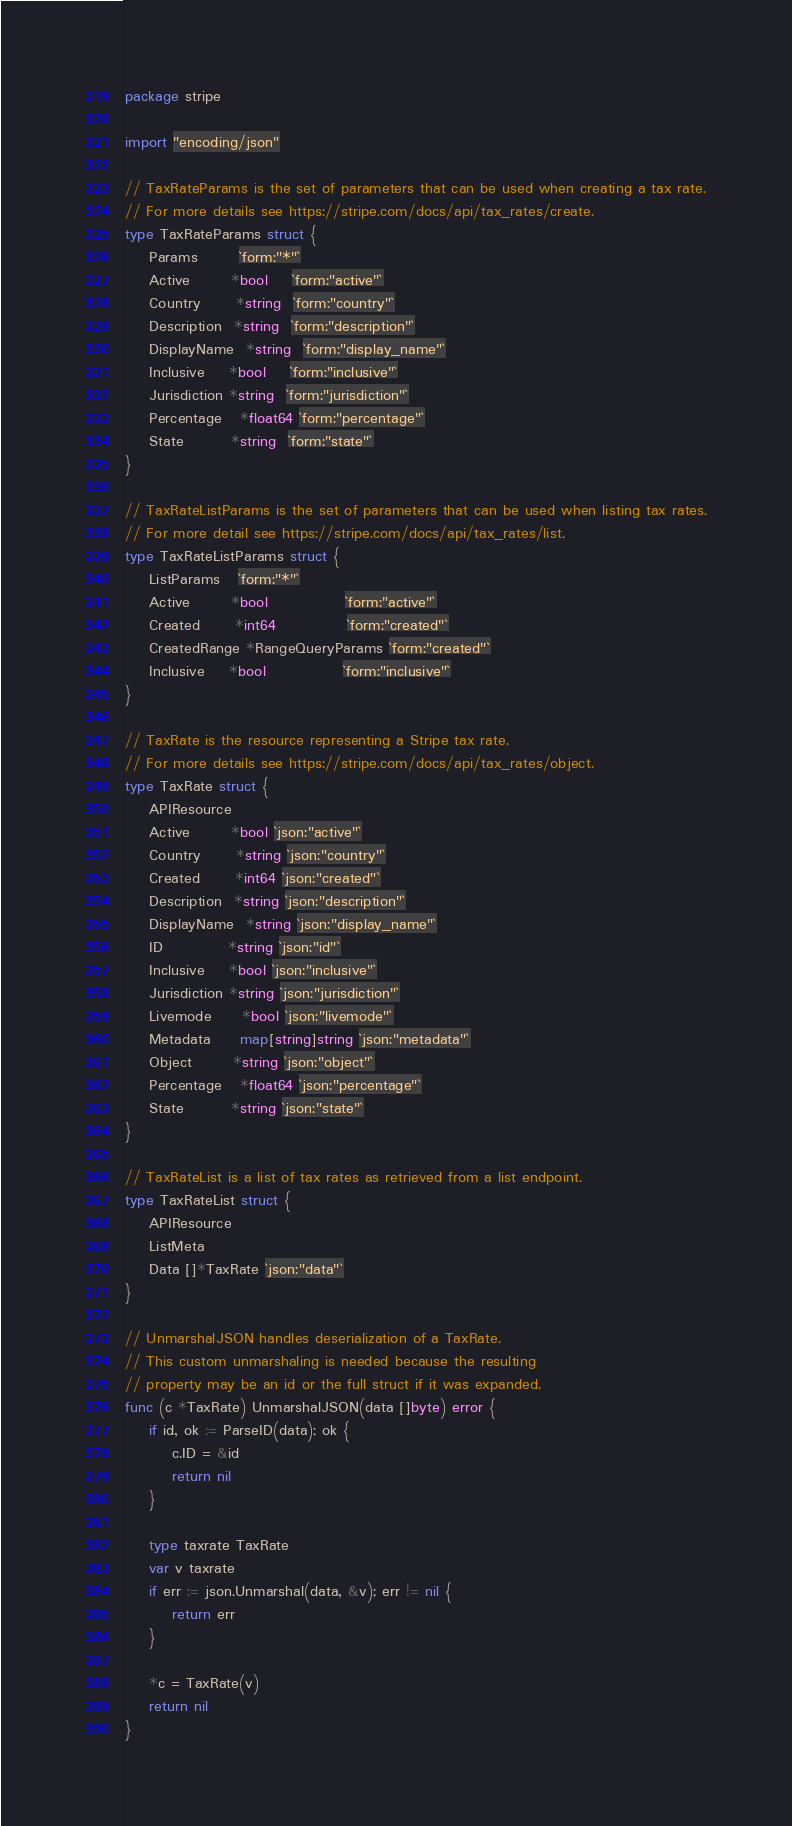<code> <loc_0><loc_0><loc_500><loc_500><_Go_>package stripe

import "encoding/json"

// TaxRateParams is the set of parameters that can be used when creating a tax rate.
// For more details see https://stripe.com/docs/api/tax_rates/create.
type TaxRateParams struct {
	Params       `form:"*"`
	Active       *bool    `form:"active"`
	Country      *string  `form:"country"`
	Description  *string  `form:"description"`
	DisplayName  *string  `form:"display_name"`
	Inclusive    *bool    `form:"inclusive"`
	Jurisdiction *string  `form:"jurisdiction"`
	Percentage   *float64 `form:"percentage"`
	State        *string  `form:"state"`
}

// TaxRateListParams is the set of parameters that can be used when listing tax rates.
// For more detail see https://stripe.com/docs/api/tax_rates/list.
type TaxRateListParams struct {
	ListParams   `form:"*"`
	Active       *bool             `form:"active"`
	Created      *int64            `form:"created"`
	CreatedRange *RangeQueryParams `form:"created"`
	Inclusive    *bool             `form:"inclusive"`
}

// TaxRate is the resource representing a Stripe tax rate.
// For more details see https://stripe.com/docs/api/tax_rates/object.
type TaxRate struct {
	APIResource
	Active       *bool `json:"active"`
	Country      *string `json:"country"`
	Created      *int64 `json:"created"`
	Description  *string `json:"description"`
	DisplayName  *string `json:"display_name"`
	ID           *string `json:"id"`
	Inclusive    *bool `json:"inclusive"`
	Jurisdiction *string `json:"jurisdiction"`
	Livemode     *bool `json:"livemode"`
	Metadata     map[string]string `json:"metadata"`
	Object       *string `json:"object"`
	Percentage   *float64 `json:"percentage"`
	State        *string `json:"state"`
}

// TaxRateList is a list of tax rates as retrieved from a list endpoint.
type TaxRateList struct {
	APIResource
	ListMeta
	Data []*TaxRate `json:"data"`
}

// UnmarshalJSON handles deserialization of a TaxRate.
// This custom unmarshaling is needed because the resulting
// property may be an id or the full struct if it was expanded.
func (c *TaxRate) UnmarshalJSON(data []byte) error {
	if id, ok := ParseID(data); ok {
		c.ID = &id
		return nil
	}

	type taxrate TaxRate
	var v taxrate
	if err := json.Unmarshal(data, &v); err != nil {
		return err
	}

	*c = TaxRate(v)
	return nil
}
</code> 